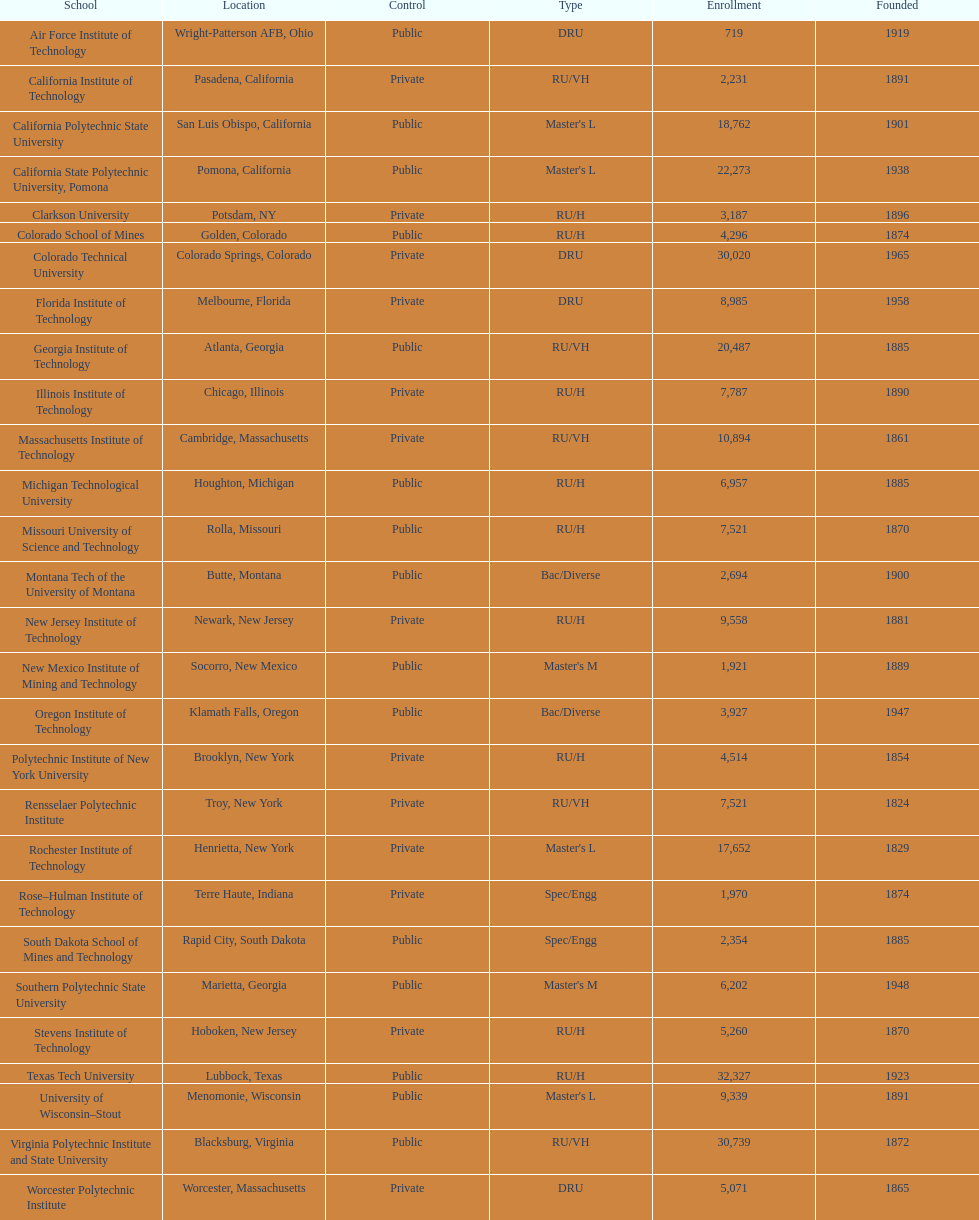What is the total number of schools listed in the table? 28. 